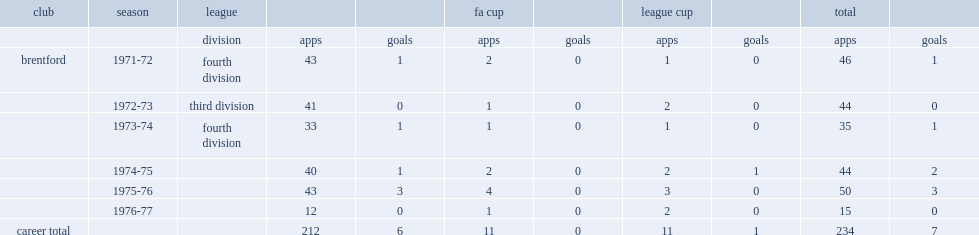How many appearances did scales score in his career? 234.0. How many goals did scales score in his career? 7.0. 